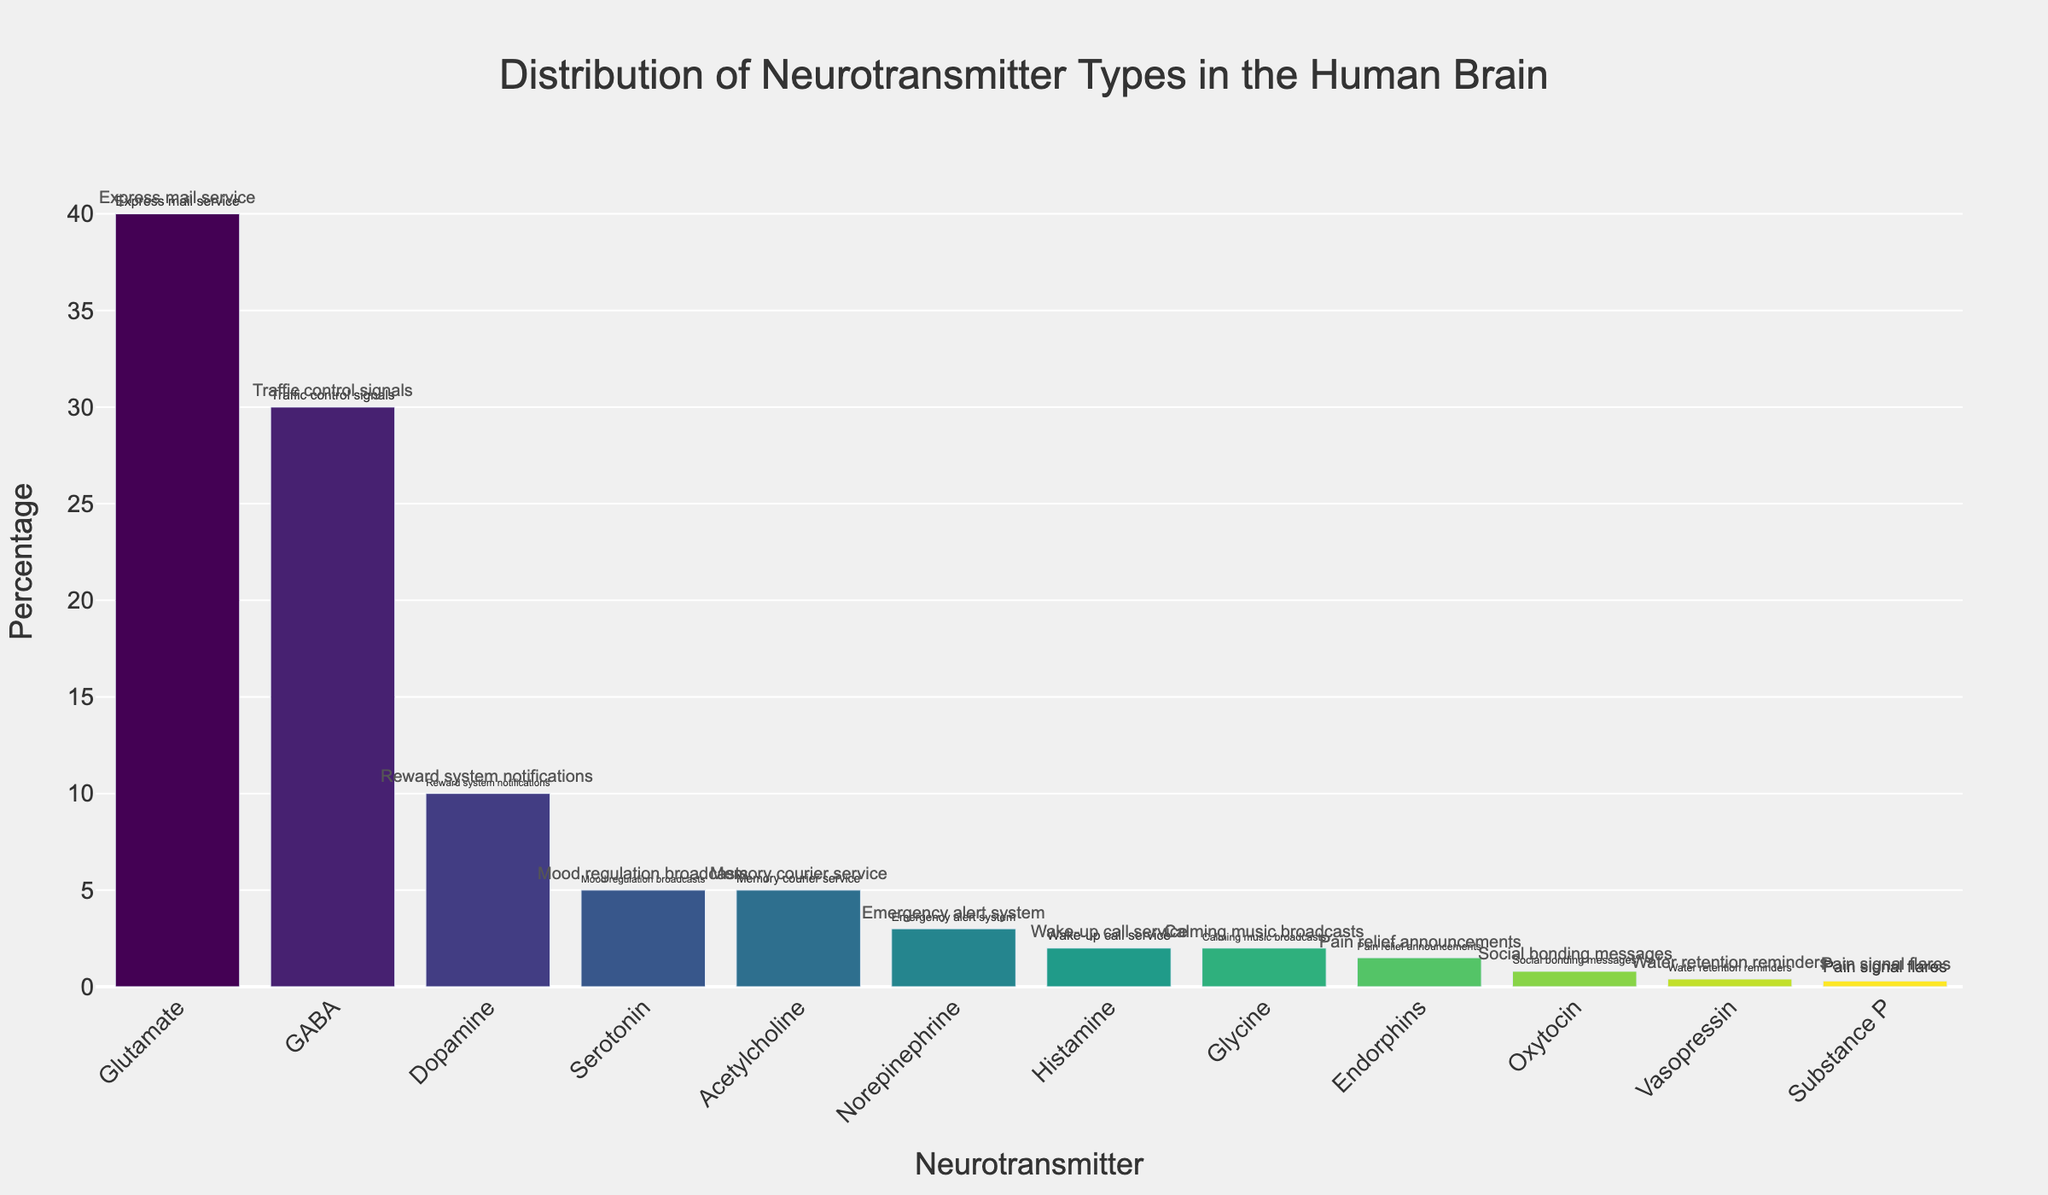What neurotransmitter has the highest percentage, and what is its city analogy? The figure's highest bar corresponds to the neurotransmitter with the highest percentage. The text on the figure indicates the city analogy.
Answer: Glutamate, Express mail service Which neurotransmitters have a percentage lower than 5%, and what are their city analogies? Examine the bars that are shorter and correspond to percentages below 5%. Read the text for their respective city analogies.
Answer: Norepinephrine (Emergency alert system), Histamine (Wake-up call service), Glycine (Calming music broadcasts), Endorphins (Pain relief announcements), Oxytocin (Social bonding messages), Vasopressin (Water retention reminders), Substance P (Pain signal flares) How many neurotransmitters in total are represented in the figure? Count the number of distinct bars representing different neurotransmitters.
Answer: 12 What is the combined percentage of GABA and Dopamine? Add the percentages of GABA and Dopamine. GABA is 30%, and Dopamine is 10%.
Answer: 40% Which neurotransmitter is represented by the same percentage as Acetylcholine, and what is its city analogy? Locate the bar for Acetylcholine and find another bar of the same height. Read the label for its city analogy.
Answer: Serotonin, Mood regulation broadcasts Compare the percentage of Glutamate and GABA. How much greater is Glutamate than GABA? Subtract the percentage of GABA from the percentage of Glutamate. Glutamate is 40%, and GABA is 30%.
Answer: 10% What neurotransmitter analogy relates to the reward system notifications, and what is its percentage? Locate the bar labeled "Reward system notifications" and read the associated percentage.
Answer: Dopamine, 10% What are the two neurotransmitters with the smallest percentages, and what are their city analogies? Identify the two shortest bars in the figure and read their city analogies.
Answer: Vasopressin (Water retention reminders), Substance P (Pain signal flares) Of the neurotransmitters, which represent less than 1% combined, and what are their analogies? Summarize the percentages and analogies for neurotransmitters where individual percentages are less than 1% until their sum is just below 1%.
Answer: Oxytocin (Social bonding messages), Vasopressin (Water retention reminders), Substance P (Pain signal flares) 